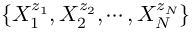<formula> <loc_0><loc_0><loc_500><loc_500>\{ X _ { 1 } ^ { z _ { 1 } } , X _ { 2 } ^ { z _ { 2 } } , \cdots , X _ { N } ^ { z _ { N } } \}</formula> 